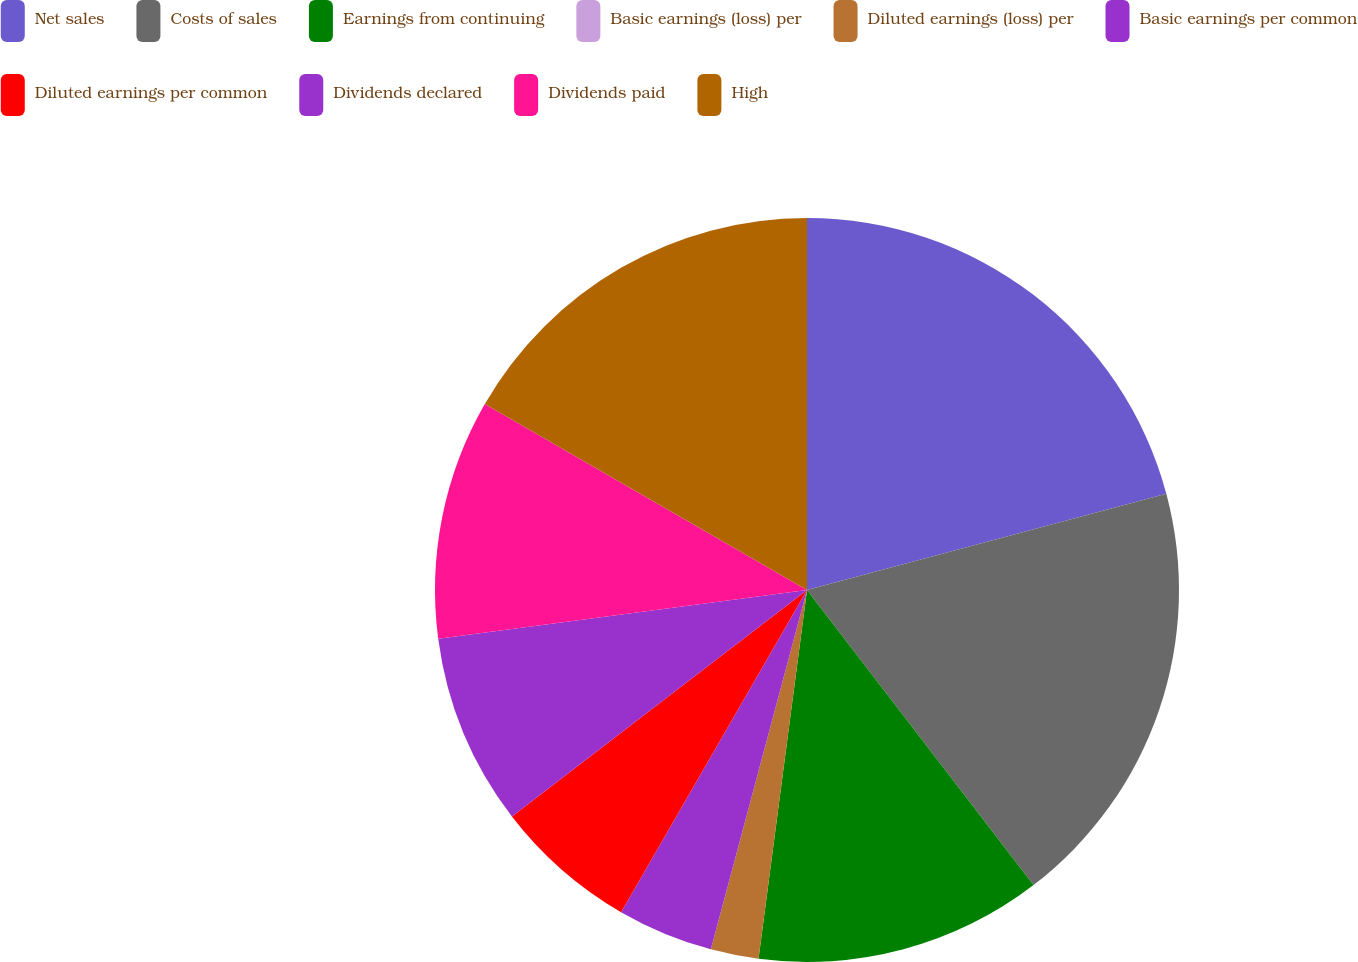<chart> <loc_0><loc_0><loc_500><loc_500><pie_chart><fcel>Net sales<fcel>Costs of sales<fcel>Earnings from continuing<fcel>Basic earnings (loss) per<fcel>Diluted earnings (loss) per<fcel>Basic earnings per common<fcel>Diluted earnings per common<fcel>Dividends declared<fcel>Dividends paid<fcel>High<nl><fcel>20.83%<fcel>18.75%<fcel>12.5%<fcel>0.0%<fcel>2.08%<fcel>4.17%<fcel>6.25%<fcel>8.33%<fcel>10.42%<fcel>16.67%<nl></chart> 